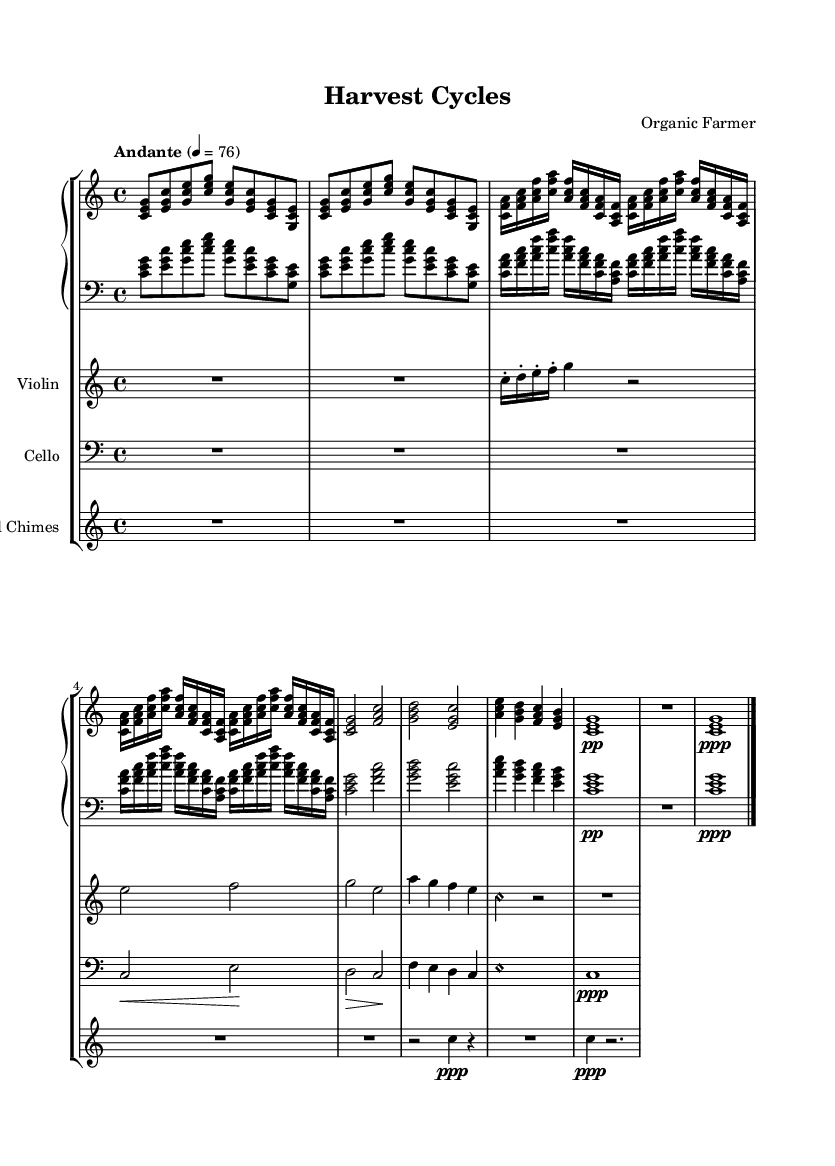What is the key signature of this music? The key signature is C major, which has no sharps or flats.
Answer: C major What is the time signature of this music? The time signature shown is 4/4, indicating four beats per measure.
Answer: 4/4 What is the tempo marking indicated in the score? The tempo marking indicates "Andante" with a metronome mark of 76, suggesting a moderately slow pace.
Answer: Andante, 76 Which instruments are featured in this composition? The score lists the instruments as Piano, Violin, Cello, and Wind Chimes, all contributing to the layered textures characteristic of minimalist music.
Answer: Piano, Violin, Cello, Wind Chimes How many sections are structured in the piece? The piece contains five main sections: Introduction, Spring, Summer, Autumn, and Winter, reflecting the cyclical nature of crop growth and seasonal changes.
Answer: Five sections What is the rhythm pattern used in the Spring section? The Spring section features a quick succession of sixteenth notes, creating a lively and bright texture that symbolizes new growth in crops.
Answer: Sixteenth notes What effect do the wind chimes have in this music? The wind chimes add a delicate, ethereal quality, representing the gentle sounds of nature and enhancing the overall minimalist aesthetic of seasonal change.
Answer: Ethereal quality 